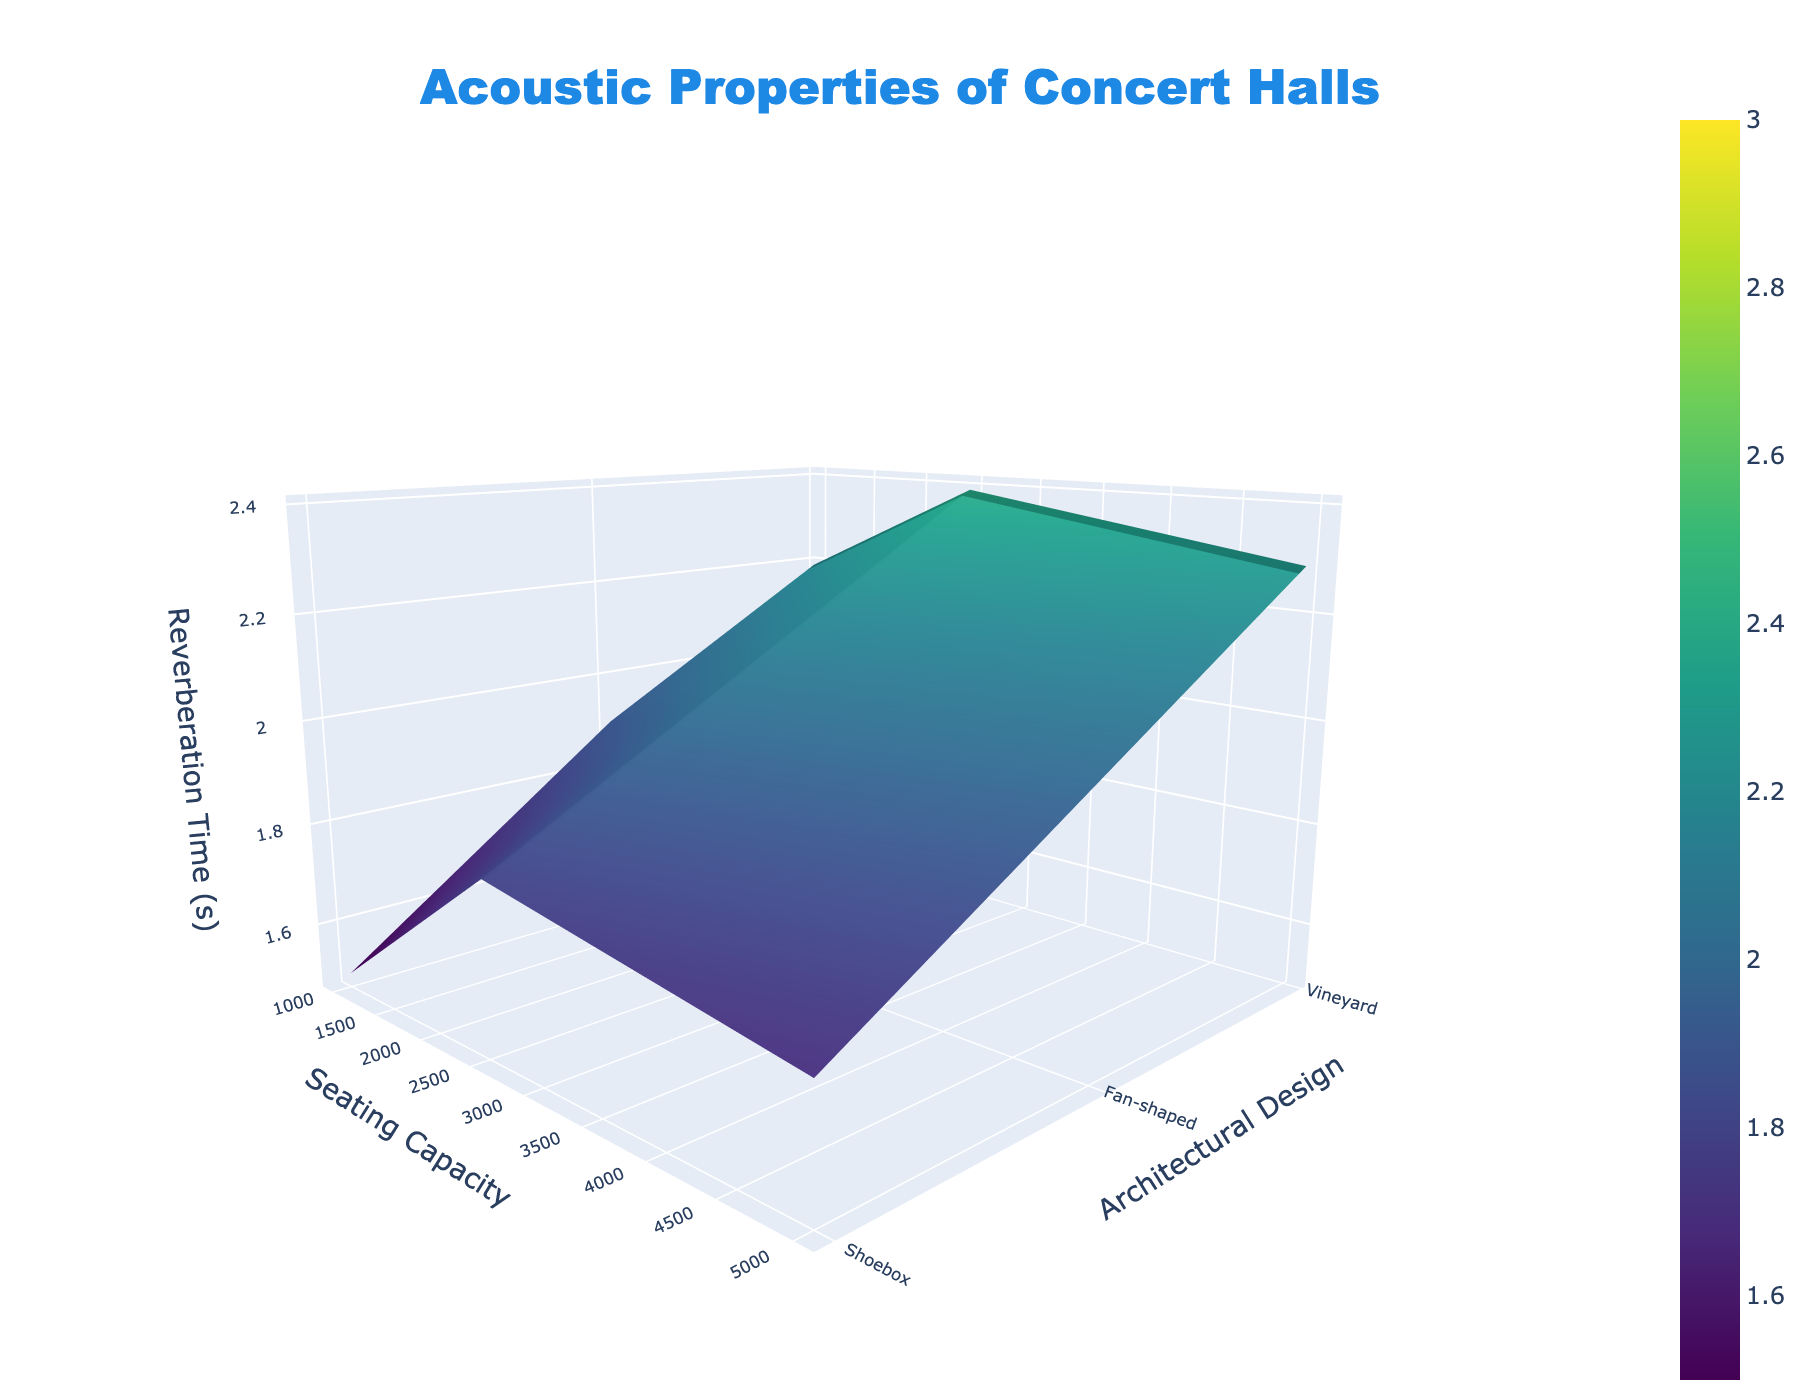What is the title of the 3D surface plot? The title is displayed at the top center of the figure in a large font and states the main topic of the plot.
Answer: Acoustic Properties of Concert Halls What does the Z-axis represent? The Z-axis is labeled 'Reverberation Time (s)', indicating that it represents the reverberation time in seconds.
Answer: Reverberation Time (s) How does the reverberation time change with seating capacity for shoebox designs? By observing the Z-values (height) for the shoebox designs as the seating capacity increases, it's clear that the reverberation time increases as the seating capacity increases.
Answer: Increases Compare the reverberation time for fan-shaped and vineyard architectural designs at 2500 seating capacity. Which one is higher? Check the Z-values for both fan-shaped and vineyard designs at the seating capacity of 2500. The fan-shaped design has a reverberation time of 1.9s, while the vineyard design has a time of 2.0s.
Answer: Vineyard Among the seating capacities given, which capacity shows the highest reverberation time for all architectural designs? Look at the highest Z-values for all architectural designs across all seating capacities. The highest values appear at the 10000 seating capacity for all architectural designs.
Answer: 10000 What is the difference in reverberation time between shoebox and fan-shaped designs at 5000 seating capacity? Subtract the reverberation time for the fan-shaped design at 5000 capacity from the time for the shoebox design at the same capacity. (2.4 - 2.2) = 0.2s
Answer: 0.2s How does the reverberation time for vineyard design change as seating capacity increases from 1000 to 10000? Observe the Z-values for vineyard designs at seating capacities 1000, 2500, 5000, 7500, and 10000. The reverberation time increases progressively: 1.7s, 2.0s, 2.3s, 2.6s, and 2.9s respectively.
Answer: Increases Which architectural design has the lowest reverberation time at 7500 seating capacity? Compare the Z-values for all architectural designs at 7500 seating capacity. The fan-shaped design has the lowest reverberation time at this capacity, which is 2.5s.
Answer: Fan-shaped Calculate the average reverberation time for the seating capacities 2500 and 5000 for shoebox design. Add the reverberation times for shoebox design at 2500 and 5000 seating capacities, then divide by 2. (2.1s + 2.4s) / 2 = 2.25s
Answer: 2.25s What is the trend of reverberation time for fan-shaped designs as seating capacity increases from 1000 to 10000? Identify the Z-values for fan-shaped designs at each level of seating capacity (1000 to 10000). The reverberation time increases in each step: 1.5s, 1.9s, 2.2s, 2.5s, and 2.8s.
Answer: Increases 